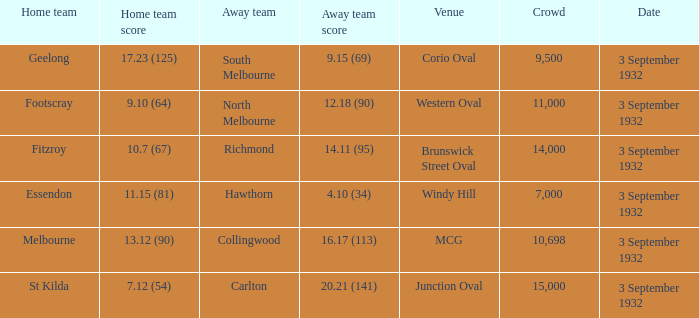What is the name of the Venue for the team that has an Away team score of 14.11 (95)? Brunswick Street Oval. 